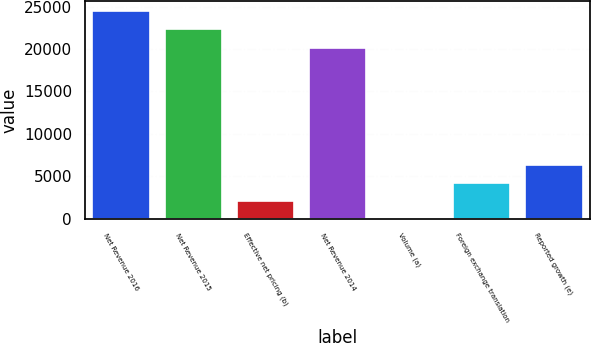Convert chart. <chart><loc_0><loc_0><loc_500><loc_500><bar_chart><fcel>Net Revenue 2016<fcel>Net Revenue 2015<fcel>Effective net pricing (b)<fcel>Net Revenue 2014<fcel>Volume (a)<fcel>Foreign exchange translation<fcel>Reported growth (e)<nl><fcel>24433.3<fcel>22302.2<fcel>2131.65<fcel>20171<fcel>0.5<fcel>4262.8<fcel>6393.95<nl></chart> 